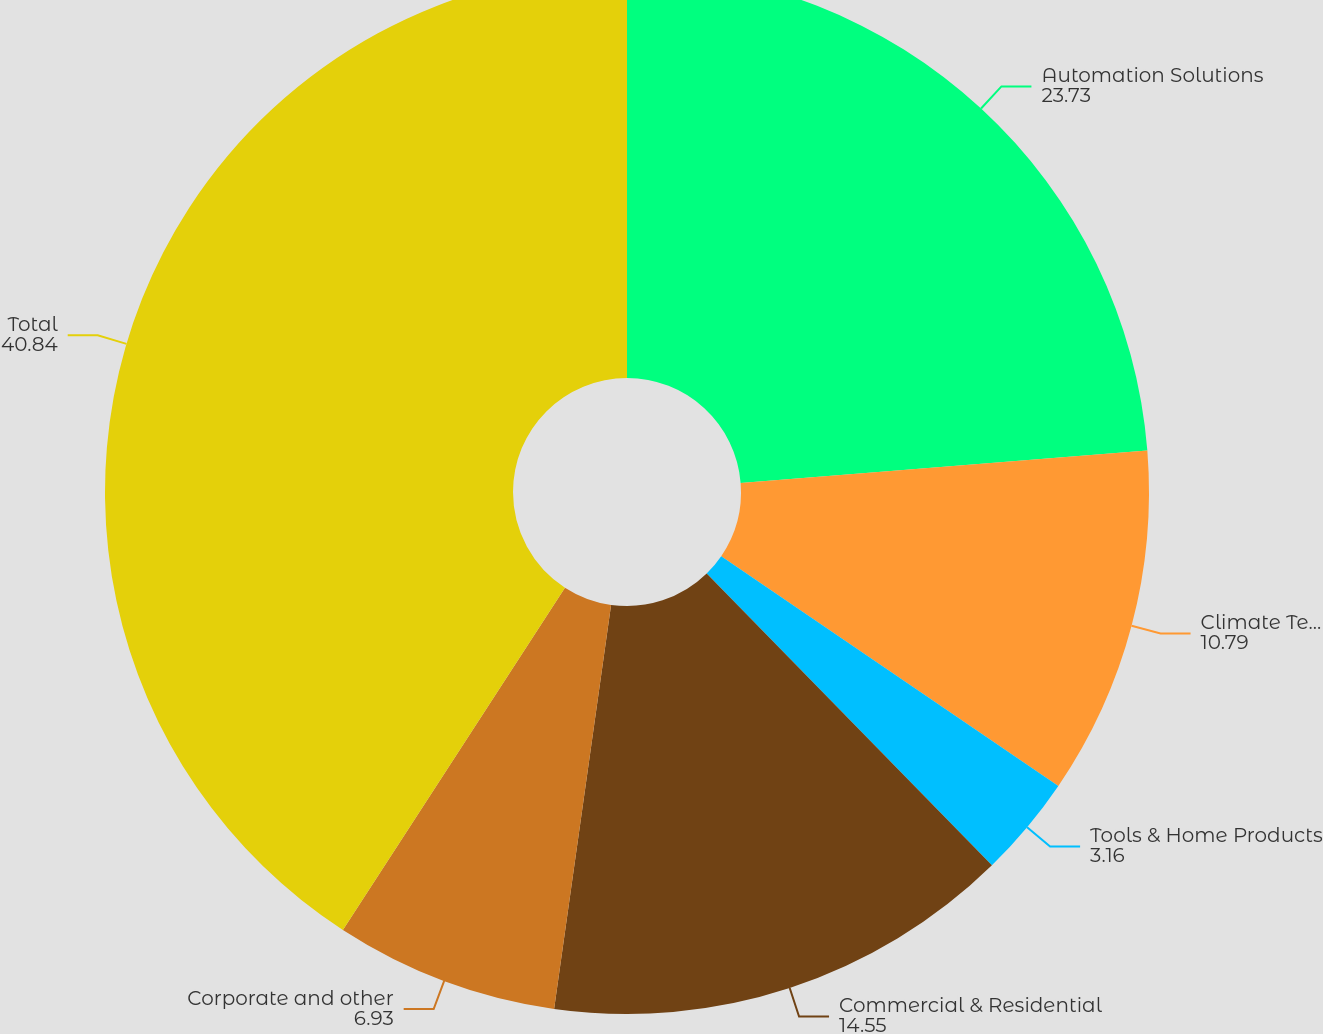Convert chart to OTSL. <chart><loc_0><loc_0><loc_500><loc_500><pie_chart><fcel>Automation Solutions<fcel>Climate Technologies<fcel>Tools & Home Products<fcel>Commercial & Residential<fcel>Corporate and other<fcel>Total<nl><fcel>23.73%<fcel>10.79%<fcel>3.16%<fcel>14.55%<fcel>6.93%<fcel>40.84%<nl></chart> 